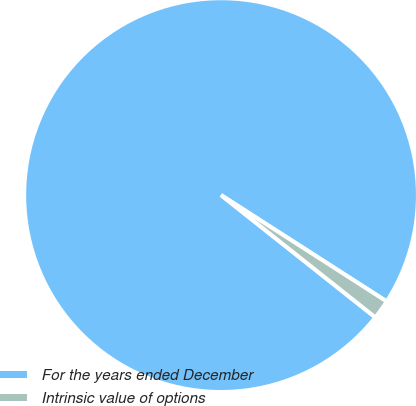Convert chart. <chart><loc_0><loc_0><loc_500><loc_500><pie_chart><fcel>For the years ended December<fcel>Intrinsic value of options<nl><fcel>98.42%<fcel>1.58%<nl></chart> 